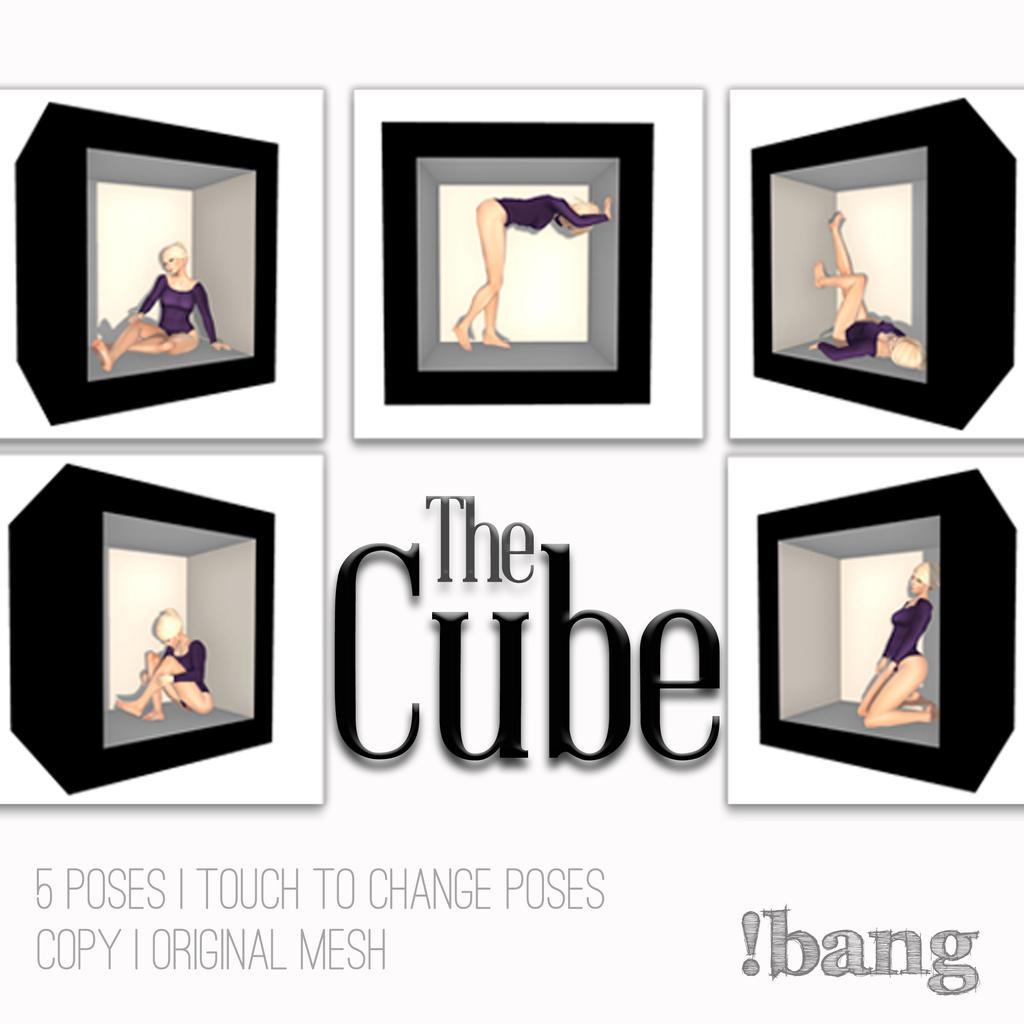Provide a one-sentence caption for the provided image. A book named The Cube 5 Poses 1 Touch to Change Poses. 